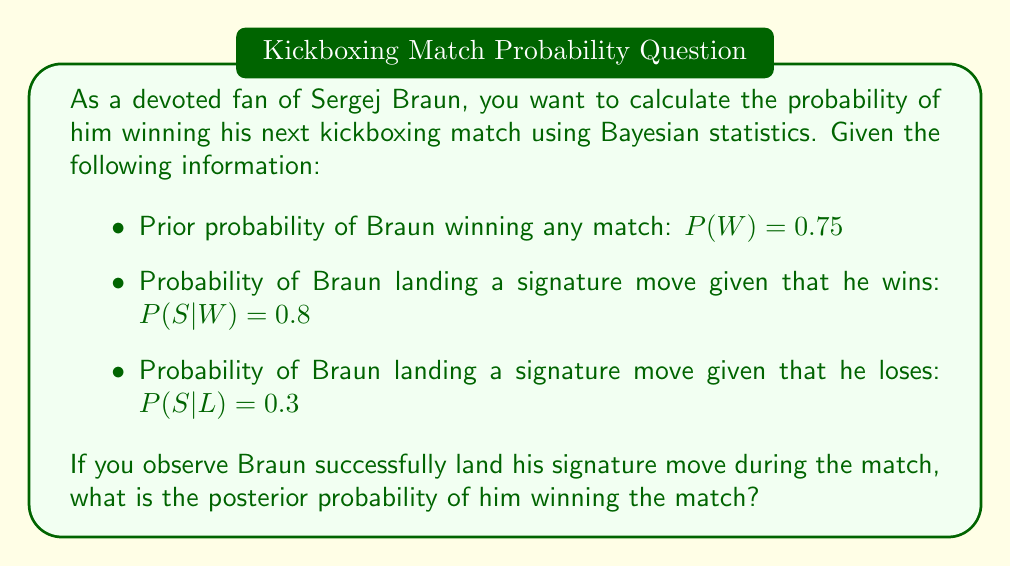Can you solve this math problem? To solve this problem, we'll use Bayes' theorem:

$$P(W|S) = \frac{P(S|W) \cdot P(W)}{P(S)}$$

Where:
$P(W|S)$ is the posterior probability of winning given that the signature move was observed
$P(S|W)$ is the likelihood of observing the signature move given that Braun wins
$P(W)$ is the prior probability of Braun winning
$P(S)$ is the total probability of observing the signature move

We need to calculate $P(S)$ using the law of total probability:

$$P(S) = P(S|W) \cdot P(W) + P(S|L) \cdot P(L)$$

First, let's calculate $P(L)$:
$P(L) = 1 - P(W) = 1 - 0.75 = 0.25$

Now we can calculate $P(S)$:
$$P(S) = 0.8 \cdot 0.75 + 0.3 \cdot 0.25 = 0.6 + 0.075 = 0.675$$

With all components ready, we can apply Bayes' theorem:

$$P(W|S) = \frac{0.8 \cdot 0.75}{0.675} = \frac{0.6}{0.675} \approx 0.8889$$
Answer: The posterior probability of Sergej Braun winning the match, given that he landed his signature move, is approximately 0.8889 or 88.89%. 